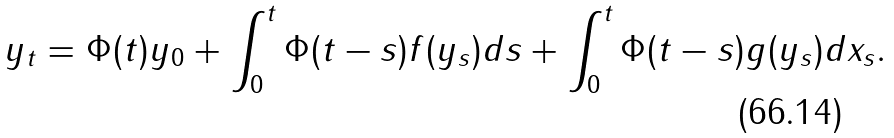<formula> <loc_0><loc_0><loc_500><loc_500>y _ { t } = \Phi ( t ) y _ { 0 } + \int _ { 0 } ^ { t } \Phi ( t - s ) f ( y _ { s } ) d s + \int _ { 0 } ^ { t } \Phi ( t - s ) g ( y _ { s } ) d x _ { s } .</formula> 